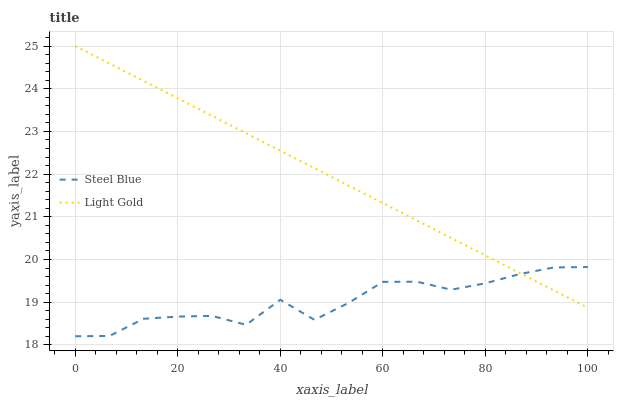Does Steel Blue have the minimum area under the curve?
Answer yes or no. Yes. Does Light Gold have the maximum area under the curve?
Answer yes or no. Yes. Does Steel Blue have the maximum area under the curve?
Answer yes or no. No. Is Light Gold the smoothest?
Answer yes or no. Yes. Is Steel Blue the roughest?
Answer yes or no. Yes. Is Steel Blue the smoothest?
Answer yes or no. No. Does Steel Blue have the lowest value?
Answer yes or no. Yes. Does Light Gold have the highest value?
Answer yes or no. Yes. Does Steel Blue have the highest value?
Answer yes or no. No. Does Steel Blue intersect Light Gold?
Answer yes or no. Yes. Is Steel Blue less than Light Gold?
Answer yes or no. No. Is Steel Blue greater than Light Gold?
Answer yes or no. No. 